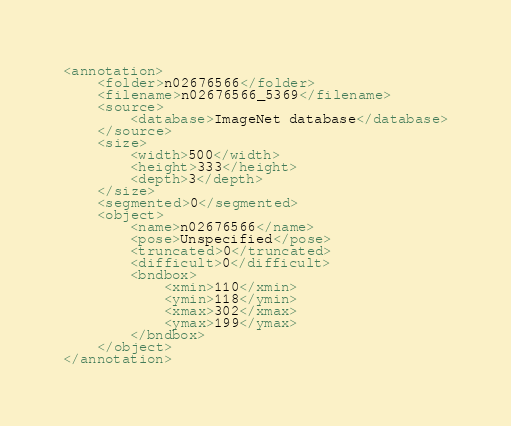<code> <loc_0><loc_0><loc_500><loc_500><_XML_><annotation>
	<folder>n02676566</folder>
	<filename>n02676566_5369</filename>
	<source>
		<database>ImageNet database</database>
	</source>
	<size>
		<width>500</width>
		<height>333</height>
		<depth>3</depth>
	</size>
	<segmented>0</segmented>
	<object>
		<name>n02676566</name>
		<pose>Unspecified</pose>
		<truncated>0</truncated>
		<difficult>0</difficult>
		<bndbox>
			<xmin>110</xmin>
			<ymin>118</ymin>
			<xmax>302</xmax>
			<ymax>199</ymax>
		</bndbox>
	</object>
</annotation></code> 